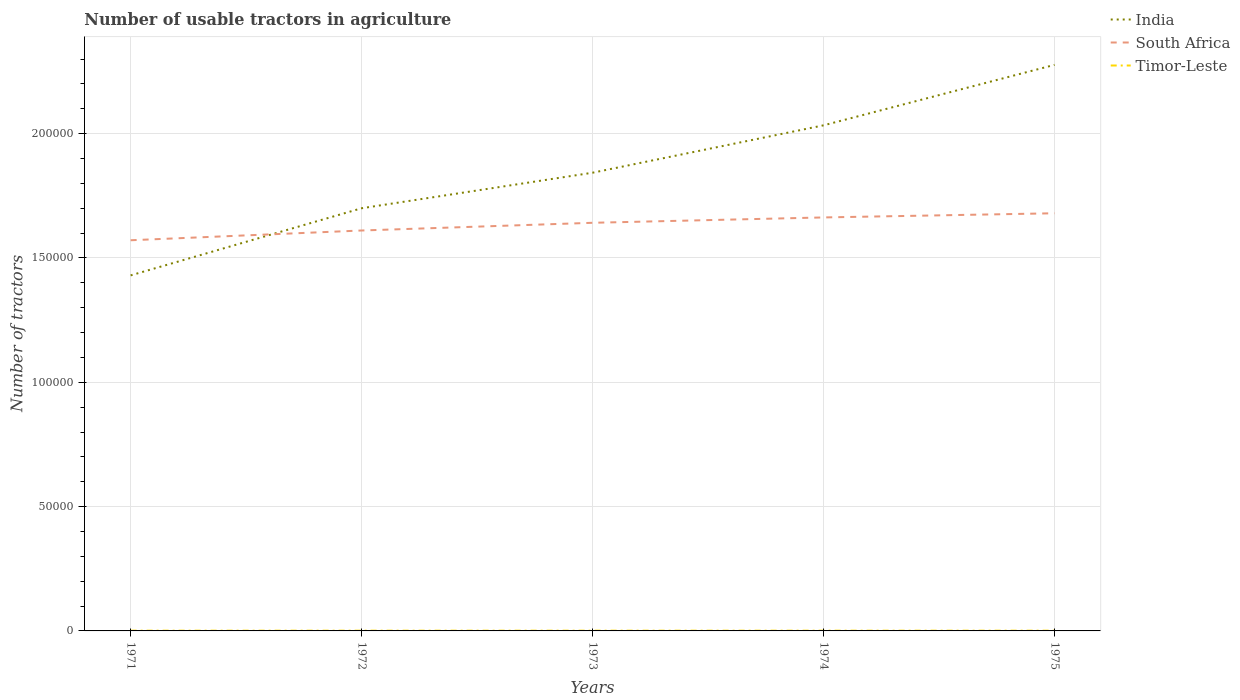Does the line corresponding to Timor-Leste intersect with the line corresponding to South Africa?
Provide a short and direct response. No. What is the total number of usable tractors in agriculture in South Africa in the graph?
Provide a succinct answer. -1.09e+04. What is the difference between the highest and the second highest number of usable tractors in agriculture in Timor-Leste?
Keep it short and to the point. 1. Is the number of usable tractors in agriculture in South Africa strictly greater than the number of usable tractors in agriculture in Timor-Leste over the years?
Give a very brief answer. No. How many years are there in the graph?
Your answer should be compact. 5. Are the values on the major ticks of Y-axis written in scientific E-notation?
Offer a very short reply. No. Does the graph contain any zero values?
Your answer should be compact. No. Does the graph contain grids?
Provide a short and direct response. Yes. What is the title of the graph?
Your answer should be very brief. Number of usable tractors in agriculture. Does "Bosnia and Herzegovina" appear as one of the legend labels in the graph?
Provide a succinct answer. No. What is the label or title of the X-axis?
Offer a terse response. Years. What is the label or title of the Y-axis?
Your answer should be very brief. Number of tractors. What is the Number of tractors of India in 1971?
Ensure brevity in your answer.  1.43e+05. What is the Number of tractors in South Africa in 1971?
Your answer should be compact. 1.57e+05. What is the Number of tractors of Timor-Leste in 1971?
Provide a succinct answer. 101. What is the Number of tractors in South Africa in 1972?
Ensure brevity in your answer.  1.61e+05. What is the Number of tractors of India in 1973?
Your answer should be very brief. 1.84e+05. What is the Number of tractors of South Africa in 1973?
Provide a succinct answer. 1.64e+05. What is the Number of tractors of India in 1974?
Offer a terse response. 2.03e+05. What is the Number of tractors in South Africa in 1974?
Your answer should be very brief. 1.66e+05. What is the Number of tractors in India in 1975?
Provide a succinct answer. 2.28e+05. What is the Number of tractors of South Africa in 1975?
Offer a very short reply. 1.68e+05. What is the Number of tractors in Timor-Leste in 1975?
Make the answer very short. 100. Across all years, what is the maximum Number of tractors in India?
Your answer should be compact. 2.28e+05. Across all years, what is the maximum Number of tractors of South Africa?
Provide a short and direct response. 1.68e+05. Across all years, what is the maximum Number of tractors of Timor-Leste?
Offer a very short reply. 101. Across all years, what is the minimum Number of tractors in India?
Provide a short and direct response. 1.43e+05. Across all years, what is the minimum Number of tractors in South Africa?
Provide a succinct answer. 1.57e+05. What is the total Number of tractors in India in the graph?
Offer a very short reply. 9.28e+05. What is the total Number of tractors of South Africa in the graph?
Your response must be concise. 8.17e+05. What is the total Number of tractors in Timor-Leste in the graph?
Provide a short and direct response. 501. What is the difference between the Number of tractors in India in 1971 and that in 1972?
Offer a very short reply. -2.70e+04. What is the difference between the Number of tractors of South Africa in 1971 and that in 1972?
Your answer should be very brief. -3925. What is the difference between the Number of tractors in Timor-Leste in 1971 and that in 1972?
Offer a terse response. 1. What is the difference between the Number of tractors in India in 1971 and that in 1973?
Give a very brief answer. -4.13e+04. What is the difference between the Number of tractors of South Africa in 1971 and that in 1973?
Give a very brief answer. -7022. What is the difference between the Number of tractors of India in 1971 and that in 1974?
Make the answer very short. -6.04e+04. What is the difference between the Number of tractors in South Africa in 1971 and that in 1974?
Your answer should be compact. -9178. What is the difference between the Number of tractors of India in 1971 and that in 1975?
Offer a terse response. -8.47e+04. What is the difference between the Number of tractors of South Africa in 1971 and that in 1975?
Provide a short and direct response. -1.09e+04. What is the difference between the Number of tractors of India in 1972 and that in 1973?
Provide a short and direct response. -1.43e+04. What is the difference between the Number of tractors of South Africa in 1972 and that in 1973?
Provide a short and direct response. -3097. What is the difference between the Number of tractors of India in 1972 and that in 1974?
Your response must be concise. -3.34e+04. What is the difference between the Number of tractors of South Africa in 1972 and that in 1974?
Make the answer very short. -5253. What is the difference between the Number of tractors of India in 1972 and that in 1975?
Keep it short and to the point. -5.77e+04. What is the difference between the Number of tractors in South Africa in 1972 and that in 1975?
Your answer should be very brief. -6929. What is the difference between the Number of tractors in India in 1973 and that in 1974?
Ensure brevity in your answer.  -1.91e+04. What is the difference between the Number of tractors of South Africa in 1973 and that in 1974?
Offer a very short reply. -2156. What is the difference between the Number of tractors in Timor-Leste in 1973 and that in 1974?
Keep it short and to the point. 0. What is the difference between the Number of tractors in India in 1973 and that in 1975?
Your answer should be very brief. -4.34e+04. What is the difference between the Number of tractors in South Africa in 1973 and that in 1975?
Provide a succinct answer. -3832. What is the difference between the Number of tractors in India in 1974 and that in 1975?
Provide a short and direct response. -2.43e+04. What is the difference between the Number of tractors in South Africa in 1974 and that in 1975?
Your answer should be compact. -1676. What is the difference between the Number of tractors of India in 1971 and the Number of tractors of South Africa in 1972?
Ensure brevity in your answer.  -1.81e+04. What is the difference between the Number of tractors of India in 1971 and the Number of tractors of Timor-Leste in 1972?
Ensure brevity in your answer.  1.43e+05. What is the difference between the Number of tractors of South Africa in 1971 and the Number of tractors of Timor-Leste in 1972?
Keep it short and to the point. 1.57e+05. What is the difference between the Number of tractors in India in 1971 and the Number of tractors in South Africa in 1973?
Offer a very short reply. -2.11e+04. What is the difference between the Number of tractors of India in 1971 and the Number of tractors of Timor-Leste in 1973?
Your response must be concise. 1.43e+05. What is the difference between the Number of tractors in South Africa in 1971 and the Number of tractors in Timor-Leste in 1973?
Give a very brief answer. 1.57e+05. What is the difference between the Number of tractors of India in 1971 and the Number of tractors of South Africa in 1974?
Offer a very short reply. -2.33e+04. What is the difference between the Number of tractors in India in 1971 and the Number of tractors in Timor-Leste in 1974?
Offer a very short reply. 1.43e+05. What is the difference between the Number of tractors in South Africa in 1971 and the Number of tractors in Timor-Leste in 1974?
Offer a terse response. 1.57e+05. What is the difference between the Number of tractors of India in 1971 and the Number of tractors of South Africa in 1975?
Ensure brevity in your answer.  -2.50e+04. What is the difference between the Number of tractors of India in 1971 and the Number of tractors of Timor-Leste in 1975?
Make the answer very short. 1.43e+05. What is the difference between the Number of tractors of South Africa in 1971 and the Number of tractors of Timor-Leste in 1975?
Your answer should be very brief. 1.57e+05. What is the difference between the Number of tractors of India in 1972 and the Number of tractors of South Africa in 1973?
Make the answer very short. 5851. What is the difference between the Number of tractors of India in 1972 and the Number of tractors of Timor-Leste in 1973?
Offer a terse response. 1.70e+05. What is the difference between the Number of tractors in South Africa in 1972 and the Number of tractors in Timor-Leste in 1973?
Your answer should be compact. 1.61e+05. What is the difference between the Number of tractors of India in 1972 and the Number of tractors of South Africa in 1974?
Provide a succinct answer. 3695. What is the difference between the Number of tractors of India in 1972 and the Number of tractors of Timor-Leste in 1974?
Give a very brief answer. 1.70e+05. What is the difference between the Number of tractors in South Africa in 1972 and the Number of tractors in Timor-Leste in 1974?
Offer a terse response. 1.61e+05. What is the difference between the Number of tractors of India in 1972 and the Number of tractors of South Africa in 1975?
Provide a succinct answer. 2019. What is the difference between the Number of tractors of India in 1972 and the Number of tractors of Timor-Leste in 1975?
Keep it short and to the point. 1.70e+05. What is the difference between the Number of tractors of South Africa in 1972 and the Number of tractors of Timor-Leste in 1975?
Your answer should be compact. 1.61e+05. What is the difference between the Number of tractors of India in 1973 and the Number of tractors of South Africa in 1974?
Offer a terse response. 1.80e+04. What is the difference between the Number of tractors of India in 1973 and the Number of tractors of Timor-Leste in 1974?
Give a very brief answer. 1.84e+05. What is the difference between the Number of tractors in South Africa in 1973 and the Number of tractors in Timor-Leste in 1974?
Provide a short and direct response. 1.64e+05. What is the difference between the Number of tractors of India in 1973 and the Number of tractors of South Africa in 1975?
Give a very brief answer. 1.63e+04. What is the difference between the Number of tractors of India in 1973 and the Number of tractors of Timor-Leste in 1975?
Your answer should be compact. 1.84e+05. What is the difference between the Number of tractors of South Africa in 1973 and the Number of tractors of Timor-Leste in 1975?
Provide a short and direct response. 1.64e+05. What is the difference between the Number of tractors of India in 1974 and the Number of tractors of South Africa in 1975?
Keep it short and to the point. 3.54e+04. What is the difference between the Number of tractors in India in 1974 and the Number of tractors in Timor-Leste in 1975?
Provide a succinct answer. 2.03e+05. What is the difference between the Number of tractors in South Africa in 1974 and the Number of tractors in Timor-Leste in 1975?
Your answer should be compact. 1.66e+05. What is the average Number of tractors in India per year?
Provide a short and direct response. 1.86e+05. What is the average Number of tractors of South Africa per year?
Your response must be concise. 1.63e+05. What is the average Number of tractors in Timor-Leste per year?
Your answer should be very brief. 100.2. In the year 1971, what is the difference between the Number of tractors in India and Number of tractors in South Africa?
Ensure brevity in your answer.  -1.41e+04. In the year 1971, what is the difference between the Number of tractors of India and Number of tractors of Timor-Leste?
Offer a terse response. 1.43e+05. In the year 1971, what is the difference between the Number of tractors in South Africa and Number of tractors in Timor-Leste?
Provide a succinct answer. 1.57e+05. In the year 1972, what is the difference between the Number of tractors in India and Number of tractors in South Africa?
Provide a short and direct response. 8948. In the year 1972, what is the difference between the Number of tractors in India and Number of tractors in Timor-Leste?
Provide a succinct answer. 1.70e+05. In the year 1972, what is the difference between the Number of tractors of South Africa and Number of tractors of Timor-Leste?
Your answer should be compact. 1.61e+05. In the year 1973, what is the difference between the Number of tractors in India and Number of tractors in South Africa?
Offer a very short reply. 2.01e+04. In the year 1973, what is the difference between the Number of tractors in India and Number of tractors in Timor-Leste?
Offer a terse response. 1.84e+05. In the year 1973, what is the difference between the Number of tractors in South Africa and Number of tractors in Timor-Leste?
Ensure brevity in your answer.  1.64e+05. In the year 1974, what is the difference between the Number of tractors of India and Number of tractors of South Africa?
Your answer should be very brief. 3.70e+04. In the year 1974, what is the difference between the Number of tractors of India and Number of tractors of Timor-Leste?
Make the answer very short. 2.03e+05. In the year 1974, what is the difference between the Number of tractors of South Africa and Number of tractors of Timor-Leste?
Keep it short and to the point. 1.66e+05. In the year 1975, what is the difference between the Number of tractors of India and Number of tractors of South Africa?
Make the answer very short. 5.97e+04. In the year 1975, what is the difference between the Number of tractors of India and Number of tractors of Timor-Leste?
Provide a short and direct response. 2.28e+05. In the year 1975, what is the difference between the Number of tractors of South Africa and Number of tractors of Timor-Leste?
Your answer should be compact. 1.68e+05. What is the ratio of the Number of tractors of India in 1971 to that in 1972?
Give a very brief answer. 0.84. What is the ratio of the Number of tractors of South Africa in 1971 to that in 1972?
Make the answer very short. 0.98. What is the ratio of the Number of tractors of India in 1971 to that in 1973?
Provide a succinct answer. 0.78. What is the ratio of the Number of tractors of South Africa in 1971 to that in 1973?
Give a very brief answer. 0.96. What is the ratio of the Number of tractors in Timor-Leste in 1971 to that in 1973?
Offer a terse response. 1.01. What is the ratio of the Number of tractors of India in 1971 to that in 1974?
Offer a terse response. 0.7. What is the ratio of the Number of tractors of South Africa in 1971 to that in 1974?
Ensure brevity in your answer.  0.94. What is the ratio of the Number of tractors of Timor-Leste in 1971 to that in 1974?
Give a very brief answer. 1.01. What is the ratio of the Number of tractors of India in 1971 to that in 1975?
Provide a short and direct response. 0.63. What is the ratio of the Number of tractors of South Africa in 1971 to that in 1975?
Your answer should be compact. 0.94. What is the ratio of the Number of tractors of Timor-Leste in 1971 to that in 1975?
Offer a terse response. 1.01. What is the ratio of the Number of tractors of India in 1972 to that in 1973?
Your answer should be very brief. 0.92. What is the ratio of the Number of tractors in South Africa in 1972 to that in 1973?
Provide a succinct answer. 0.98. What is the ratio of the Number of tractors in India in 1972 to that in 1974?
Offer a terse response. 0.84. What is the ratio of the Number of tractors of South Africa in 1972 to that in 1974?
Your answer should be very brief. 0.97. What is the ratio of the Number of tractors in India in 1972 to that in 1975?
Offer a terse response. 0.75. What is the ratio of the Number of tractors in South Africa in 1972 to that in 1975?
Make the answer very short. 0.96. What is the ratio of the Number of tractors in Timor-Leste in 1972 to that in 1975?
Provide a short and direct response. 1. What is the ratio of the Number of tractors of India in 1973 to that in 1974?
Ensure brevity in your answer.  0.91. What is the ratio of the Number of tractors in South Africa in 1973 to that in 1974?
Make the answer very short. 0.99. What is the ratio of the Number of tractors in Timor-Leste in 1973 to that in 1974?
Your answer should be very brief. 1. What is the ratio of the Number of tractors of India in 1973 to that in 1975?
Your answer should be very brief. 0.81. What is the ratio of the Number of tractors of South Africa in 1973 to that in 1975?
Give a very brief answer. 0.98. What is the ratio of the Number of tractors of India in 1974 to that in 1975?
Ensure brevity in your answer.  0.89. What is the ratio of the Number of tractors of Timor-Leste in 1974 to that in 1975?
Give a very brief answer. 1. What is the difference between the highest and the second highest Number of tractors in India?
Your response must be concise. 2.43e+04. What is the difference between the highest and the second highest Number of tractors in South Africa?
Ensure brevity in your answer.  1676. What is the difference between the highest and the second highest Number of tractors of Timor-Leste?
Provide a short and direct response. 1. What is the difference between the highest and the lowest Number of tractors of India?
Offer a very short reply. 8.47e+04. What is the difference between the highest and the lowest Number of tractors in South Africa?
Your response must be concise. 1.09e+04. 